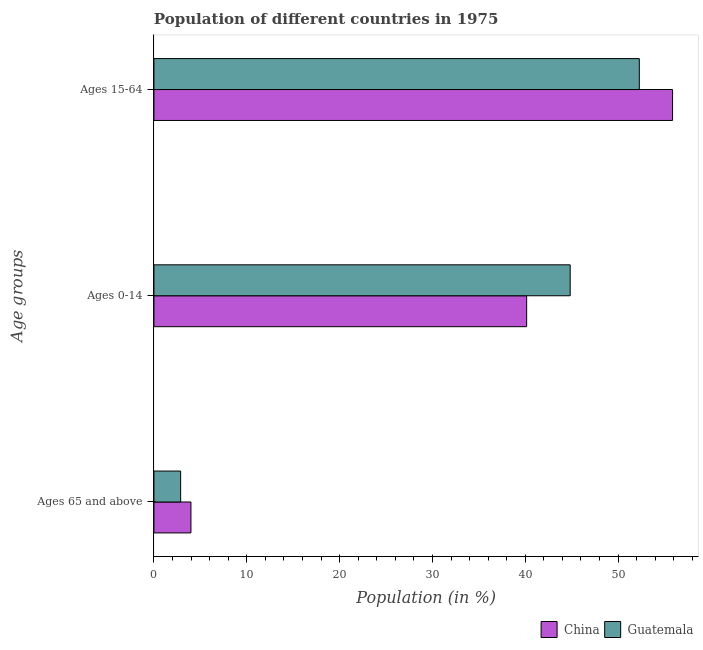Are the number of bars on each tick of the Y-axis equal?
Offer a terse response. Yes. How many bars are there on the 1st tick from the top?
Provide a succinct answer. 2. How many bars are there on the 1st tick from the bottom?
Give a very brief answer. 2. What is the label of the 2nd group of bars from the top?
Provide a succinct answer. Ages 0-14. What is the percentage of population within the age-group of 65 and above in China?
Offer a terse response. 3.99. Across all countries, what is the maximum percentage of population within the age-group 0-14?
Keep it short and to the point. 44.84. Across all countries, what is the minimum percentage of population within the age-group 0-14?
Make the answer very short. 40.15. In which country was the percentage of population within the age-group 0-14 maximum?
Make the answer very short. Guatemala. In which country was the percentage of population within the age-group of 65 and above minimum?
Ensure brevity in your answer.  Guatemala. What is the total percentage of population within the age-group of 65 and above in the graph?
Keep it short and to the point. 6.87. What is the difference between the percentage of population within the age-group 0-14 in China and that in Guatemala?
Ensure brevity in your answer.  -4.69. What is the difference between the percentage of population within the age-group of 65 and above in Guatemala and the percentage of population within the age-group 15-64 in China?
Offer a very short reply. -52.99. What is the average percentage of population within the age-group 0-14 per country?
Keep it short and to the point. 42.49. What is the difference between the percentage of population within the age-group 15-64 and percentage of population within the age-group 0-14 in China?
Offer a very short reply. 15.72. In how many countries, is the percentage of population within the age-group 15-64 greater than 18 %?
Your response must be concise. 2. What is the ratio of the percentage of population within the age-group of 65 and above in Guatemala to that in China?
Offer a terse response. 0.72. Is the difference between the percentage of population within the age-group 15-64 in China and Guatemala greater than the difference between the percentage of population within the age-group of 65 and above in China and Guatemala?
Provide a succinct answer. Yes. What is the difference between the highest and the second highest percentage of population within the age-group 0-14?
Your answer should be compact. 4.69. What is the difference between the highest and the lowest percentage of population within the age-group 15-64?
Your response must be concise. 3.58. In how many countries, is the percentage of population within the age-group 15-64 greater than the average percentage of population within the age-group 15-64 taken over all countries?
Your answer should be very brief. 1. What does the 2nd bar from the top in Ages 65 and above represents?
Provide a short and direct response. China. What does the 1st bar from the bottom in Ages 15-64 represents?
Offer a terse response. China. How many bars are there?
Offer a very short reply. 6. Are the values on the major ticks of X-axis written in scientific E-notation?
Provide a succinct answer. No. Does the graph contain any zero values?
Your answer should be compact. No. Does the graph contain grids?
Your answer should be compact. No. How many legend labels are there?
Give a very brief answer. 2. What is the title of the graph?
Make the answer very short. Population of different countries in 1975. Does "Micronesia" appear as one of the legend labels in the graph?
Your answer should be compact. No. What is the label or title of the Y-axis?
Keep it short and to the point. Age groups. What is the Population (in %) in China in Ages 65 and above?
Provide a short and direct response. 3.99. What is the Population (in %) of Guatemala in Ages 65 and above?
Provide a succinct answer. 2.88. What is the Population (in %) in China in Ages 0-14?
Give a very brief answer. 40.15. What is the Population (in %) in Guatemala in Ages 0-14?
Provide a short and direct response. 44.84. What is the Population (in %) of China in Ages 15-64?
Your answer should be very brief. 55.86. What is the Population (in %) in Guatemala in Ages 15-64?
Your answer should be compact. 52.28. Across all Age groups, what is the maximum Population (in %) of China?
Make the answer very short. 55.86. Across all Age groups, what is the maximum Population (in %) of Guatemala?
Offer a terse response. 52.28. Across all Age groups, what is the minimum Population (in %) of China?
Make the answer very short. 3.99. Across all Age groups, what is the minimum Population (in %) in Guatemala?
Give a very brief answer. 2.88. What is the total Population (in %) of China in the graph?
Your answer should be very brief. 100. What is the total Population (in %) of Guatemala in the graph?
Offer a very short reply. 100. What is the difference between the Population (in %) of China in Ages 65 and above and that in Ages 0-14?
Your answer should be very brief. -36.16. What is the difference between the Population (in %) in Guatemala in Ages 65 and above and that in Ages 0-14?
Keep it short and to the point. -41.96. What is the difference between the Population (in %) of China in Ages 65 and above and that in Ages 15-64?
Keep it short and to the point. -51.88. What is the difference between the Population (in %) in Guatemala in Ages 65 and above and that in Ages 15-64?
Offer a very short reply. -49.4. What is the difference between the Population (in %) of China in Ages 0-14 and that in Ages 15-64?
Your answer should be compact. -15.72. What is the difference between the Population (in %) in Guatemala in Ages 0-14 and that in Ages 15-64?
Your answer should be compact. -7.45. What is the difference between the Population (in %) of China in Ages 65 and above and the Population (in %) of Guatemala in Ages 0-14?
Your answer should be very brief. -40.85. What is the difference between the Population (in %) in China in Ages 65 and above and the Population (in %) in Guatemala in Ages 15-64?
Your response must be concise. -48.3. What is the difference between the Population (in %) in China in Ages 0-14 and the Population (in %) in Guatemala in Ages 15-64?
Offer a terse response. -12.14. What is the average Population (in %) in China per Age groups?
Keep it short and to the point. 33.33. What is the average Population (in %) in Guatemala per Age groups?
Ensure brevity in your answer.  33.33. What is the difference between the Population (in %) in China and Population (in %) in Guatemala in Ages 65 and above?
Ensure brevity in your answer.  1.11. What is the difference between the Population (in %) in China and Population (in %) in Guatemala in Ages 0-14?
Ensure brevity in your answer.  -4.69. What is the difference between the Population (in %) in China and Population (in %) in Guatemala in Ages 15-64?
Make the answer very short. 3.58. What is the ratio of the Population (in %) in China in Ages 65 and above to that in Ages 0-14?
Offer a terse response. 0.1. What is the ratio of the Population (in %) in Guatemala in Ages 65 and above to that in Ages 0-14?
Provide a short and direct response. 0.06. What is the ratio of the Population (in %) of China in Ages 65 and above to that in Ages 15-64?
Your answer should be very brief. 0.07. What is the ratio of the Population (in %) in Guatemala in Ages 65 and above to that in Ages 15-64?
Provide a succinct answer. 0.06. What is the ratio of the Population (in %) in China in Ages 0-14 to that in Ages 15-64?
Your answer should be compact. 0.72. What is the ratio of the Population (in %) in Guatemala in Ages 0-14 to that in Ages 15-64?
Keep it short and to the point. 0.86. What is the difference between the highest and the second highest Population (in %) in China?
Provide a short and direct response. 15.72. What is the difference between the highest and the second highest Population (in %) in Guatemala?
Ensure brevity in your answer.  7.45. What is the difference between the highest and the lowest Population (in %) of China?
Your answer should be very brief. 51.88. What is the difference between the highest and the lowest Population (in %) of Guatemala?
Provide a succinct answer. 49.4. 